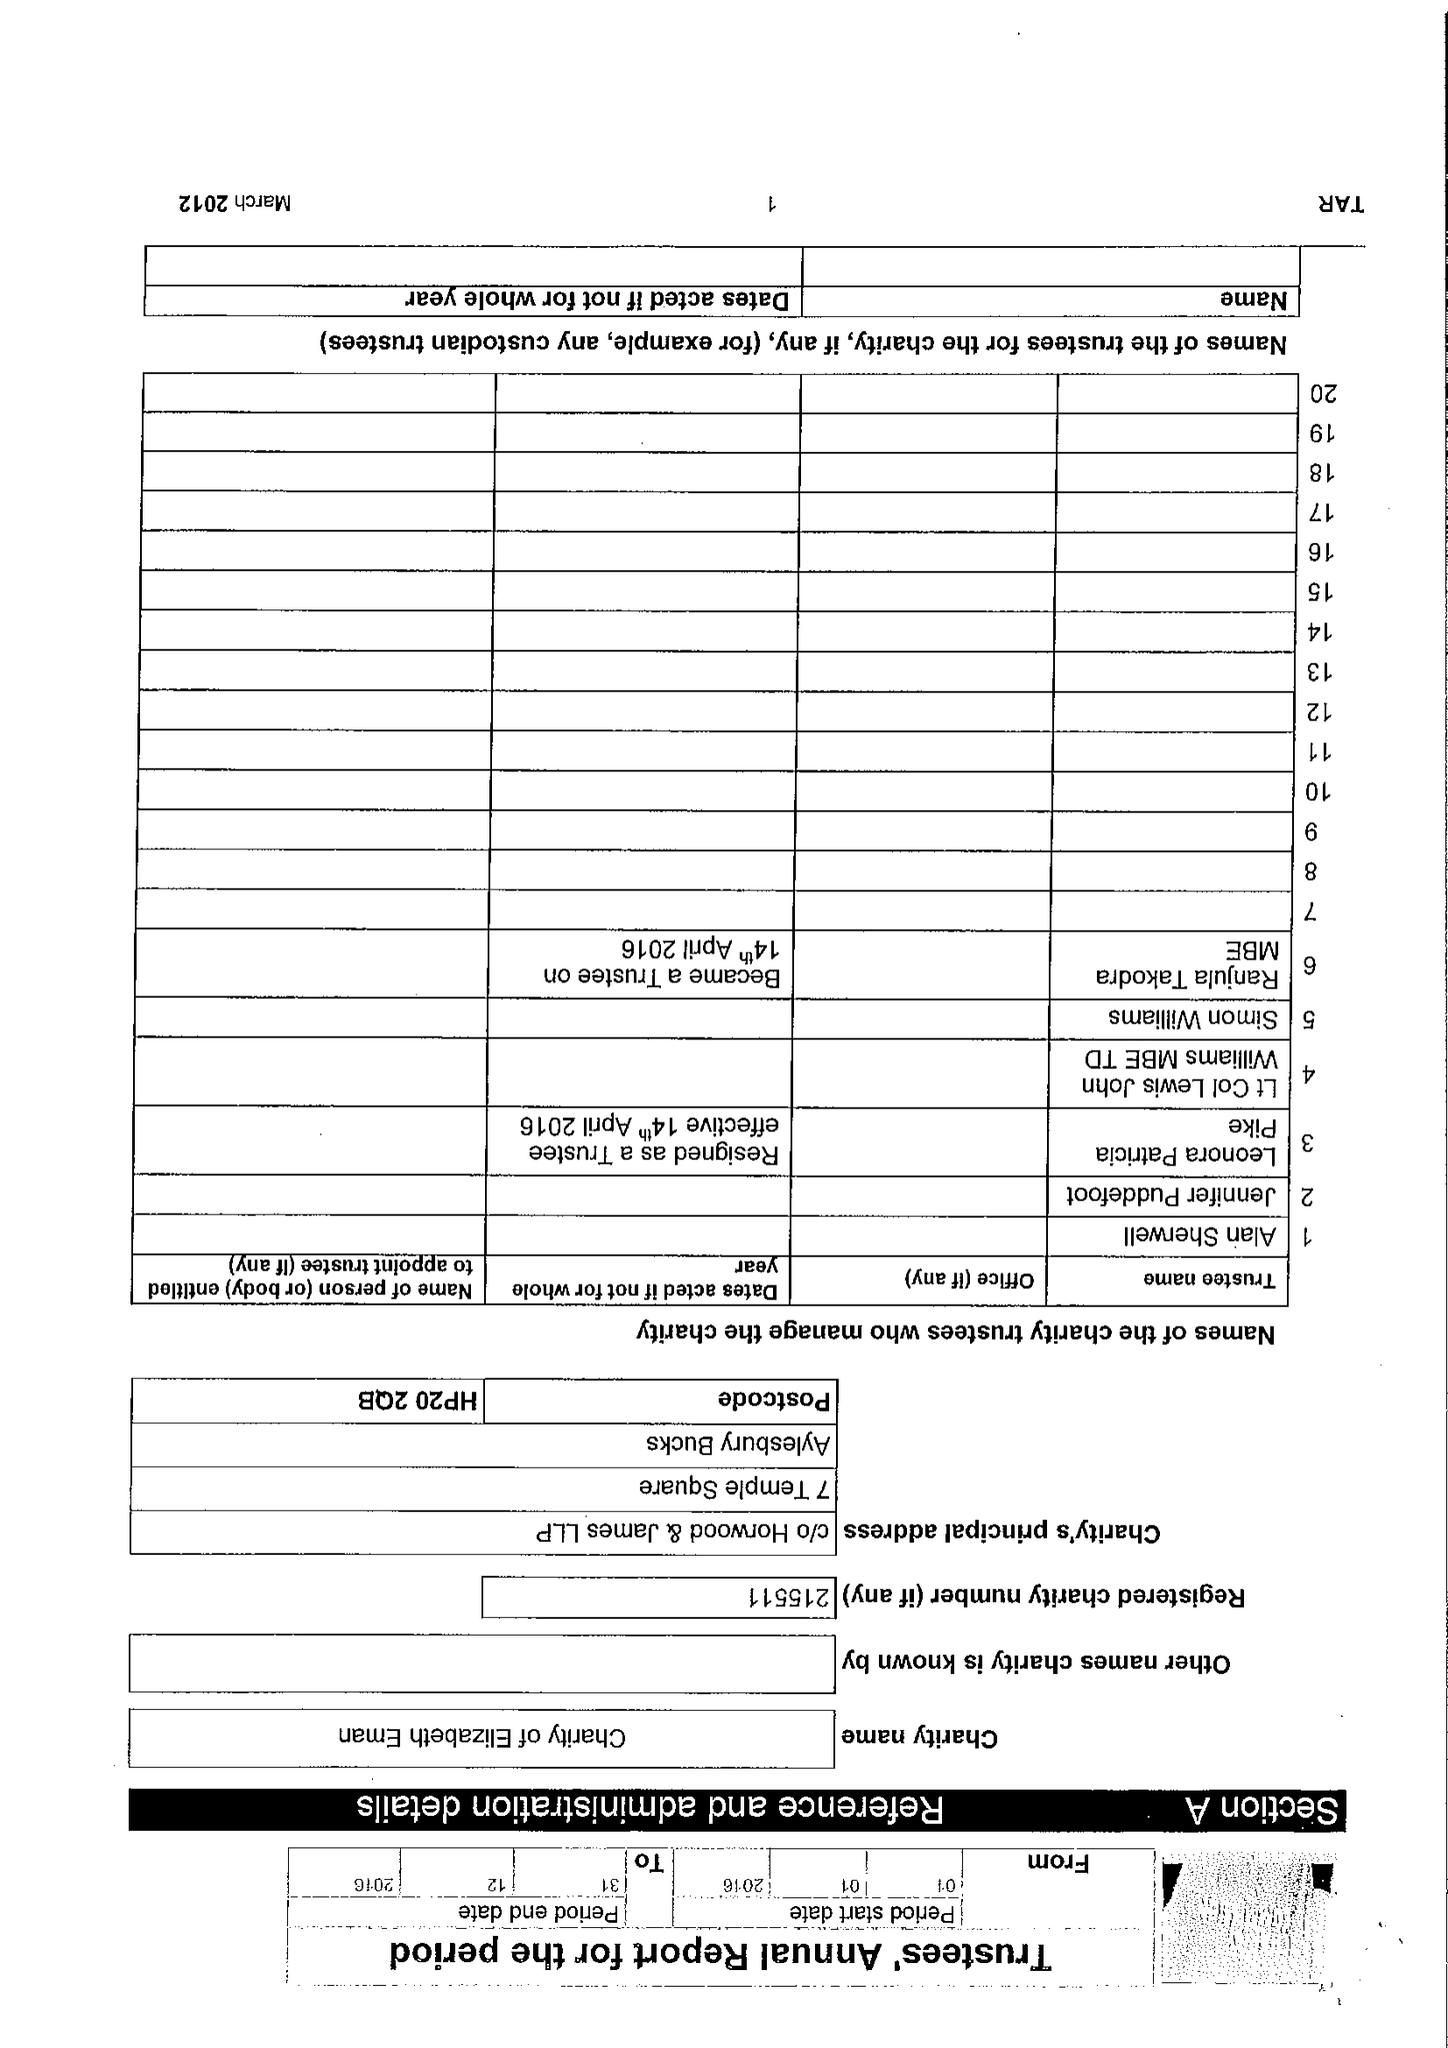What is the value for the address__post_town?
Answer the question using a single word or phrase. AYLESBURY 